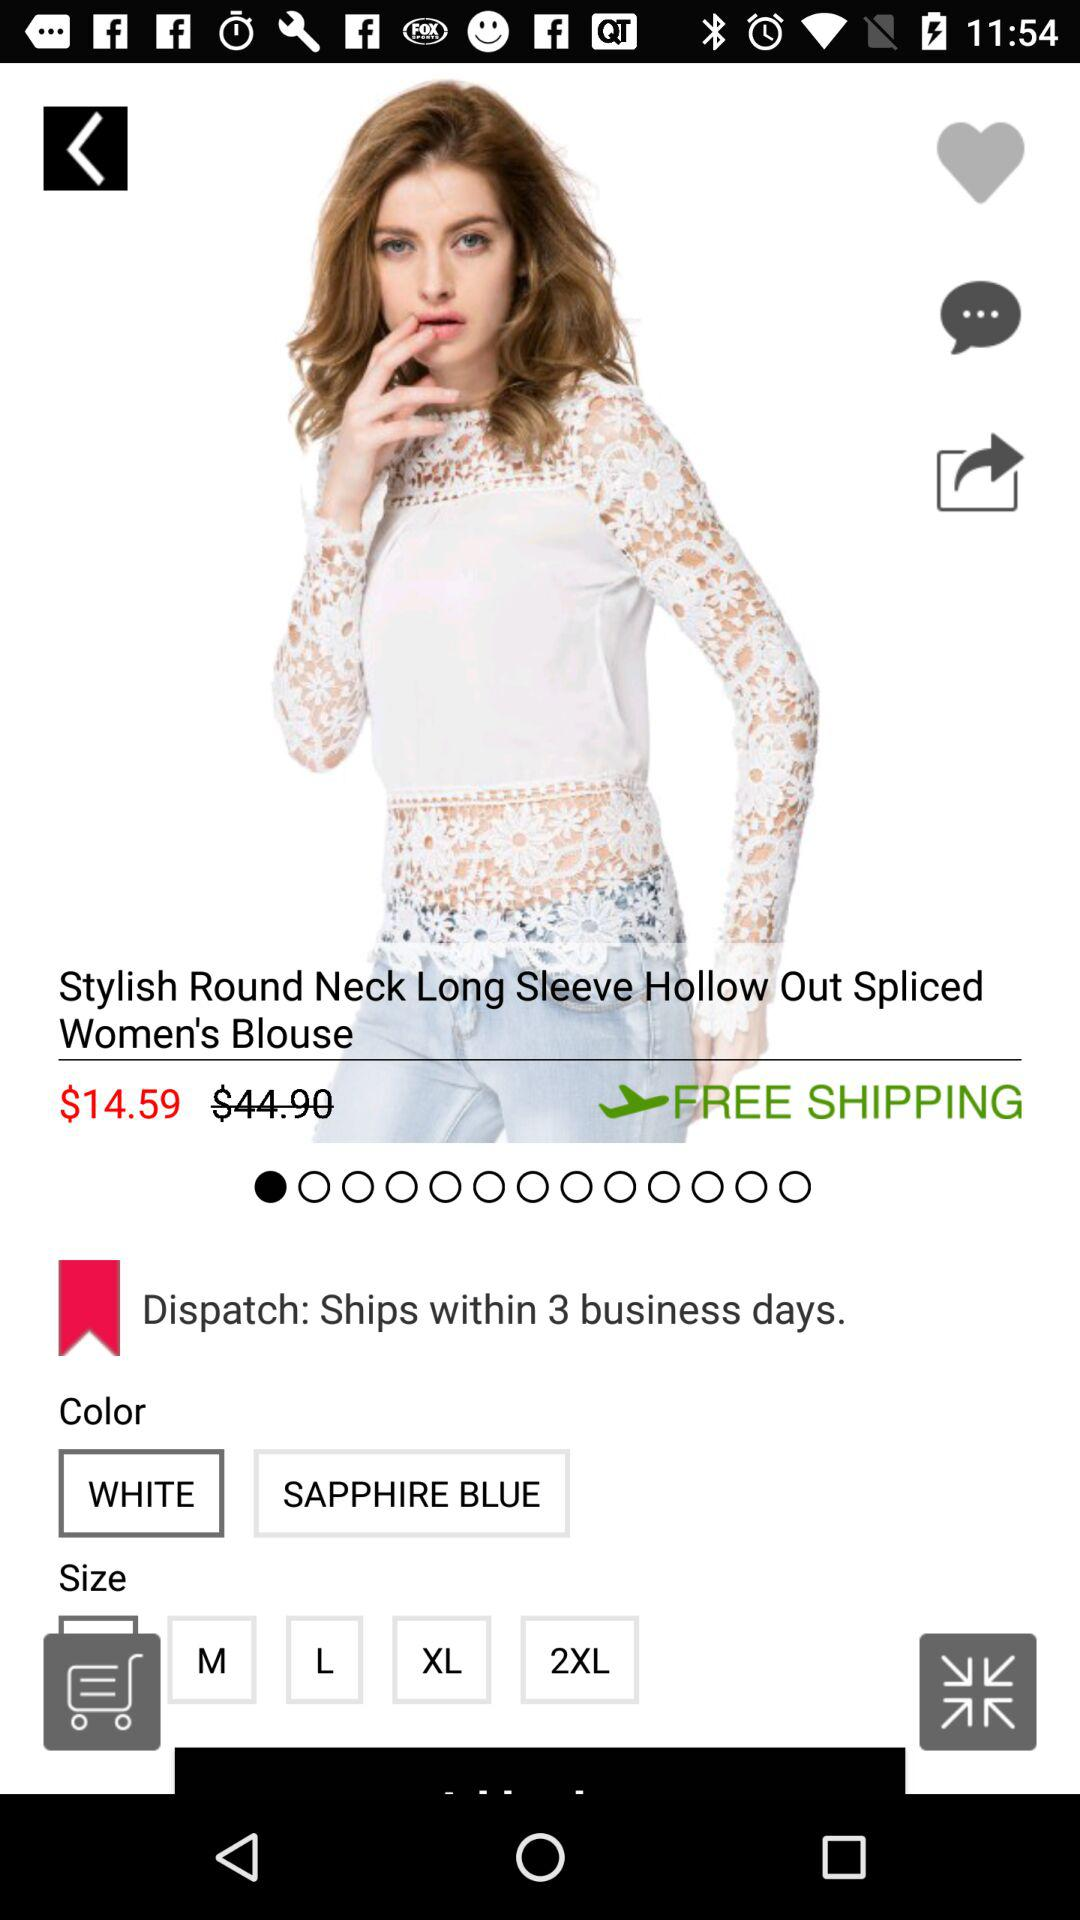What sizes are available? The available sizes are M, L, XL and 2XL. 